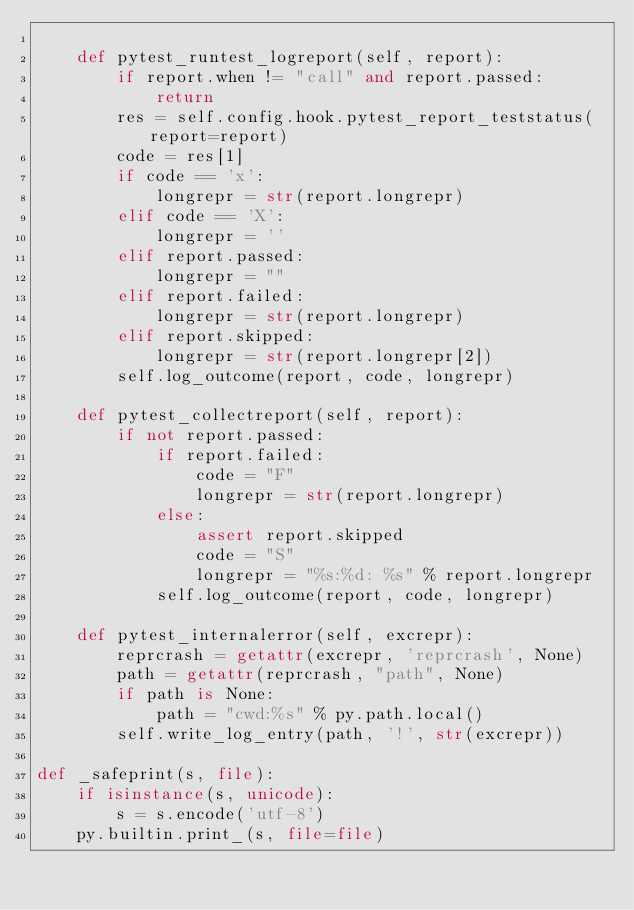<code> <loc_0><loc_0><loc_500><loc_500><_Python_>
    def pytest_runtest_logreport(self, report):
        if report.when != "call" and report.passed:
            return
        res = self.config.hook.pytest_report_teststatus(report=report)
        code = res[1]
        if code == 'x':
            longrepr = str(report.longrepr)
        elif code == 'X':
            longrepr = ''
        elif report.passed:
            longrepr = ""
        elif report.failed:
            longrepr = str(report.longrepr)
        elif report.skipped:
            longrepr = str(report.longrepr[2])
        self.log_outcome(report, code, longrepr)

    def pytest_collectreport(self, report):
        if not report.passed:
            if report.failed:
                code = "F"
                longrepr = str(report.longrepr)
            else:
                assert report.skipped
                code = "S"
                longrepr = "%s:%d: %s" % report.longrepr
            self.log_outcome(report, code, longrepr)

    def pytest_internalerror(self, excrepr):
        reprcrash = getattr(excrepr, 'reprcrash', None)
        path = getattr(reprcrash, "path", None)
        if path is None:
            path = "cwd:%s" % py.path.local()
        self.write_log_entry(path, '!', str(excrepr))

def _safeprint(s, file):
    if isinstance(s, unicode):
        s = s.encode('utf-8')
    py.builtin.print_(s, file=file)
</code> 